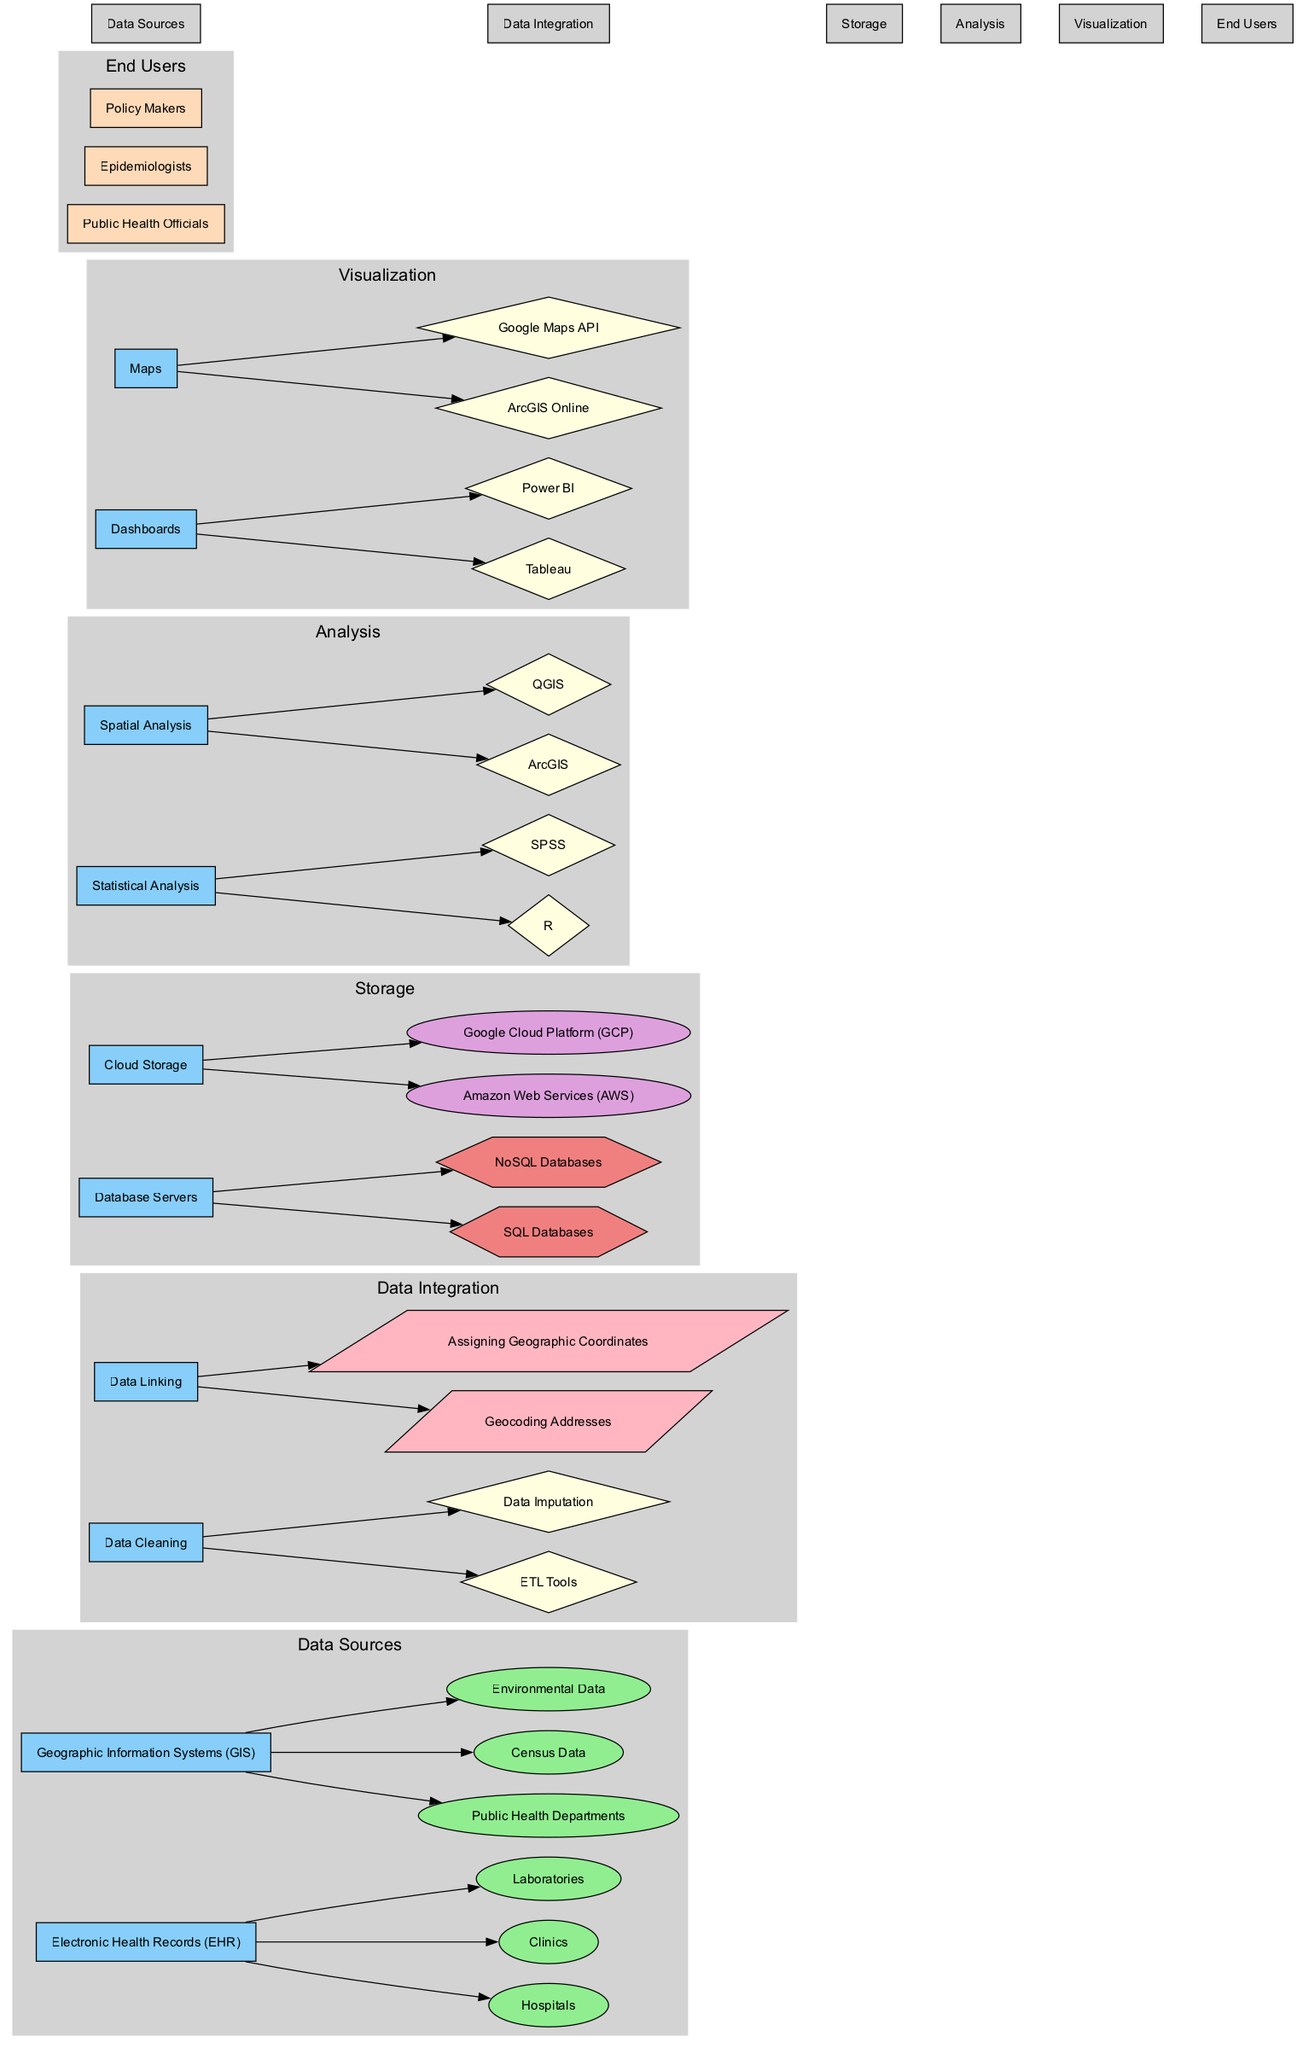What are the two main data sources in the diagram? The diagram shows "Electronic Health Records (EHR)" and "Geographic Information Systems (GIS)" as the two main data sources, identified in the "Data Sources" block.
Answer: Electronic Health Records (EHR), Geographic Information Systems (GIS) How many components are under Data Integration? The "Data Integration" block includes two components: "Data Cleaning" and "Data Linking." Thus, the number of components is calculated by simply counting them in that section.
Answer: 2 Which tool is used for Statistical Analysis? The "Analysis" block lists "R" and "SPSS" as tools for statistical analysis, making it straightforward to identify one of the tools in this sub-block.
Answer: R What type of database is mentioned in the Storage section? The "Storage" block includes "SQL Databases" and "NoSQL Databases" as types of database servers, which can be extracted by reviewing the components of that section.
Answer: SQL Databases Which storage provider is not included under Cloud Storage? The "Cloud Storage" component lists "Amazon Web Services (AWS)" and "Google Cloud Platform (GCP)" as providers, indicating that any other provider outside of this list is not included.
Answer: None Which component directly connects to Map visualization? The "Visualization" block connects to "Maps," which can be derived by checking the components that cover visualization methods. Therefore, the component linked here is specifically under visualization tools.
Answer: Maps How many types of end users are represented? The "End Users" block comprises three types: "Public Health Officials," "Epidemiologists," and "Policy Makers." Counting these figures provides the numerical answer to the question.
Answer: 3 What method is employed in Data Linking? Under "Data Linking," the diagram specifies "Geocoding Addresses" and "Assigning Geographic Coordinates" as methods, making it clear from reviewing the links under this component.
Answer: Geocoding Addresses Which analysis tool is used with GIS? The "Spatial Analysis" component mentions "ArcGIS" and "QGIS," which can be identified clearly within the "Analysis" section, indicating specific tools for spatial considerations.
Answer: ArcGIS 